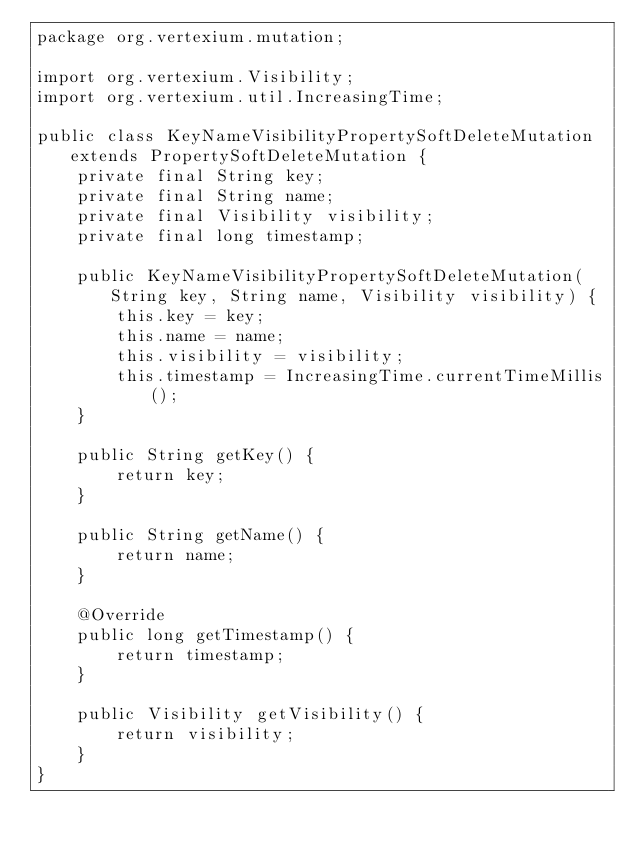<code> <loc_0><loc_0><loc_500><loc_500><_Java_>package org.vertexium.mutation;

import org.vertexium.Visibility;
import org.vertexium.util.IncreasingTime;

public class KeyNameVisibilityPropertySoftDeleteMutation extends PropertySoftDeleteMutation {
    private final String key;
    private final String name;
    private final Visibility visibility;
    private final long timestamp;

    public KeyNameVisibilityPropertySoftDeleteMutation(String key, String name, Visibility visibility) {
        this.key = key;
        this.name = name;
        this.visibility = visibility;
        this.timestamp = IncreasingTime.currentTimeMillis();
    }

    public String getKey() {
        return key;
    }

    public String getName() {
        return name;
    }

    @Override
    public long getTimestamp() {
        return timestamp;
    }

    public Visibility getVisibility() {
        return visibility;
    }
}
</code> 